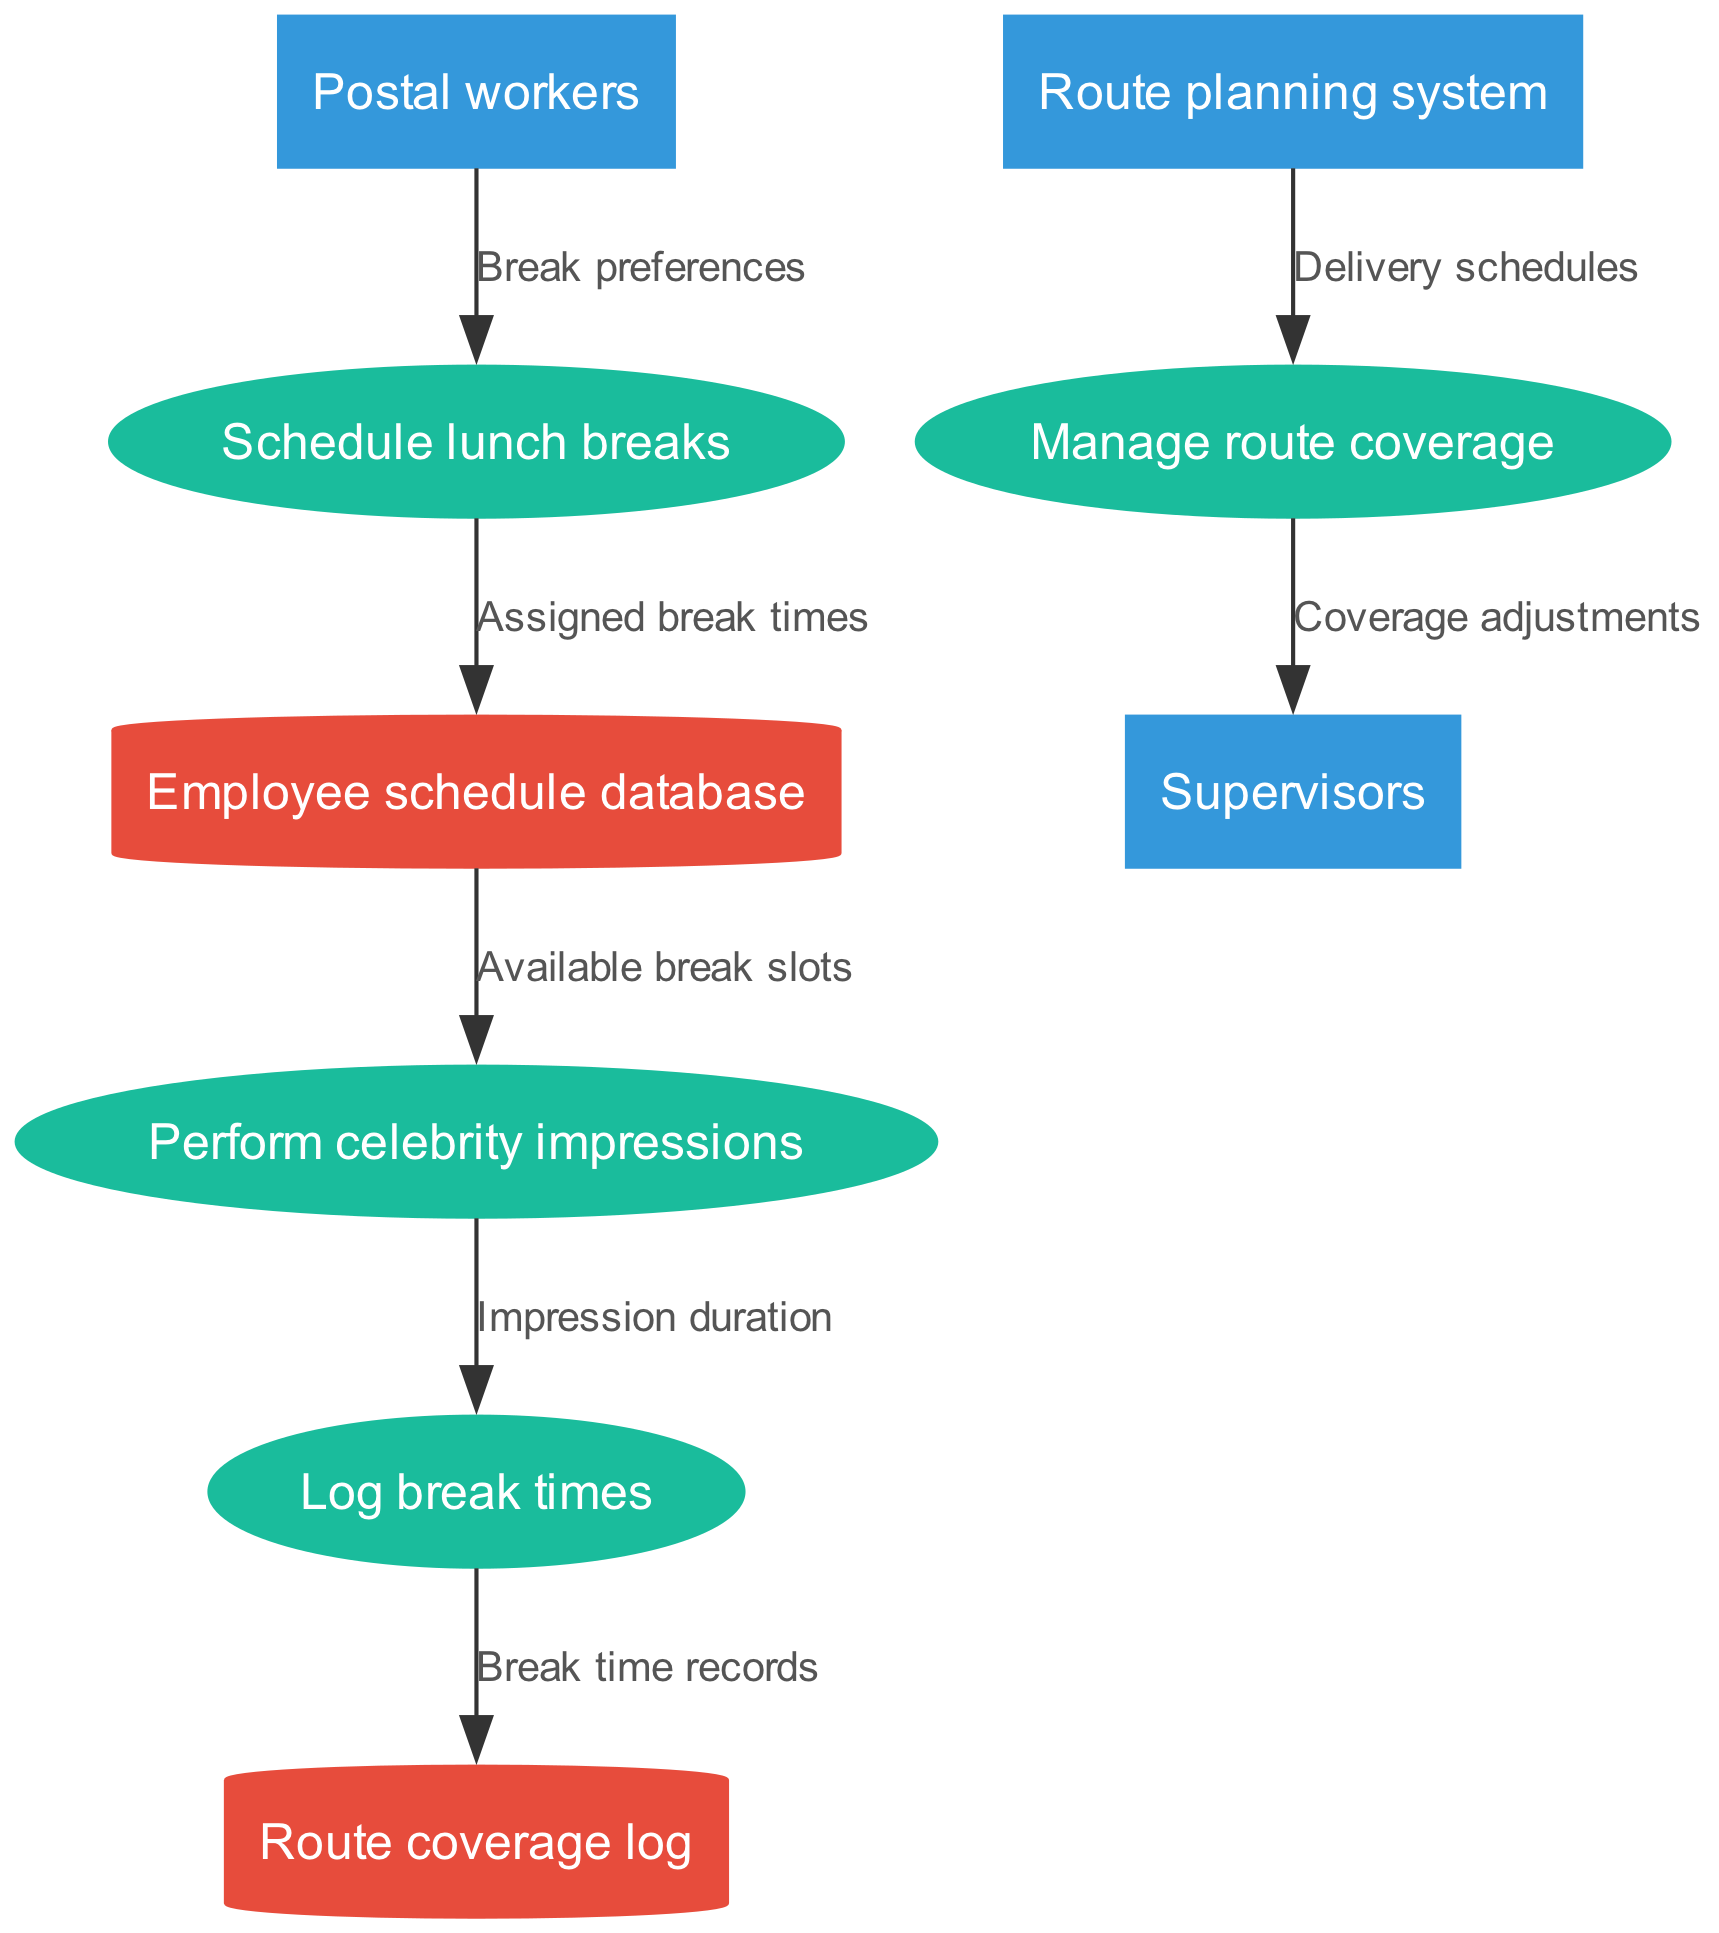What processes are included in the diagram? The diagram includes four processes: Schedule lunch breaks, Perform celebrity impressions, Log break times, and Manage route coverage.
Answer: Schedule lunch breaks, Perform celebrity impressions, Log break times, Manage route coverage How many data stores are present in the diagram? There are two data stores identified in the diagram: Employee schedule database and Route coverage log.
Answer: 2 Which entity provides break preferences? The external entity that provides break preferences is Postal workers.
Answer: Postal workers What information flows from the Schedule lunch breaks process to the Employee schedule database? The information that flows from the Schedule lunch breaks process to the Employee schedule database is Assigned break times.
Answer: Assigned break times What does the Manage route coverage process output to Supervisors? The Manage route coverage process outputs Coverage adjustments to Supervisors.
Answer: Coverage adjustments What is logged after performing celebrity impressions? After performing celebrity impressions, the Log break times process logs Impression duration.
Answer: Impression duration How does the Route planning system influence Manage route coverage? The Route planning system influences Manage route coverage by providing Delivery schedules.
Answer: Delivery schedules What is the purpose of the Log break times process? The purpose of the Log break times process is to create Break time records.
Answer: Break time records What type of diagram is represented here? The diagram represents a Data Flow Diagram (DFD), which visually outlines the data processes and flows in the lunch break scheduling system for postal workers.
Answer: Data Flow Diagram 